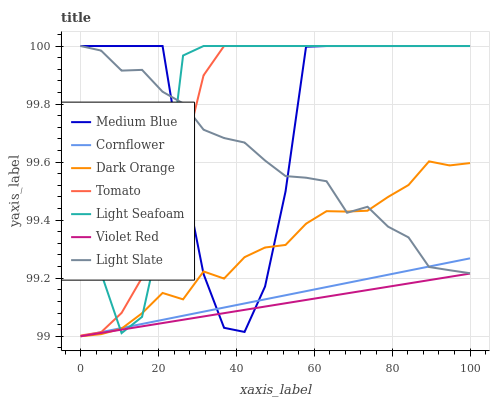Does Violet Red have the minimum area under the curve?
Answer yes or no. Yes. Does Light Seafoam have the maximum area under the curve?
Answer yes or no. Yes. Does Cornflower have the minimum area under the curve?
Answer yes or no. No. Does Cornflower have the maximum area under the curve?
Answer yes or no. No. Is Cornflower the smoothest?
Answer yes or no. Yes. Is Medium Blue the roughest?
Answer yes or no. Yes. Is Violet Red the smoothest?
Answer yes or no. No. Is Violet Red the roughest?
Answer yes or no. No. Does Cornflower have the lowest value?
Answer yes or no. Yes. Does Light Slate have the lowest value?
Answer yes or no. No. Does Light Seafoam have the highest value?
Answer yes or no. Yes. Does Cornflower have the highest value?
Answer yes or no. No. Is Violet Red less than Tomato?
Answer yes or no. Yes. Is Tomato greater than Dark Orange?
Answer yes or no. Yes. Does Tomato intersect Light Seafoam?
Answer yes or no. Yes. Is Tomato less than Light Seafoam?
Answer yes or no. No. Is Tomato greater than Light Seafoam?
Answer yes or no. No. Does Violet Red intersect Tomato?
Answer yes or no. No. 